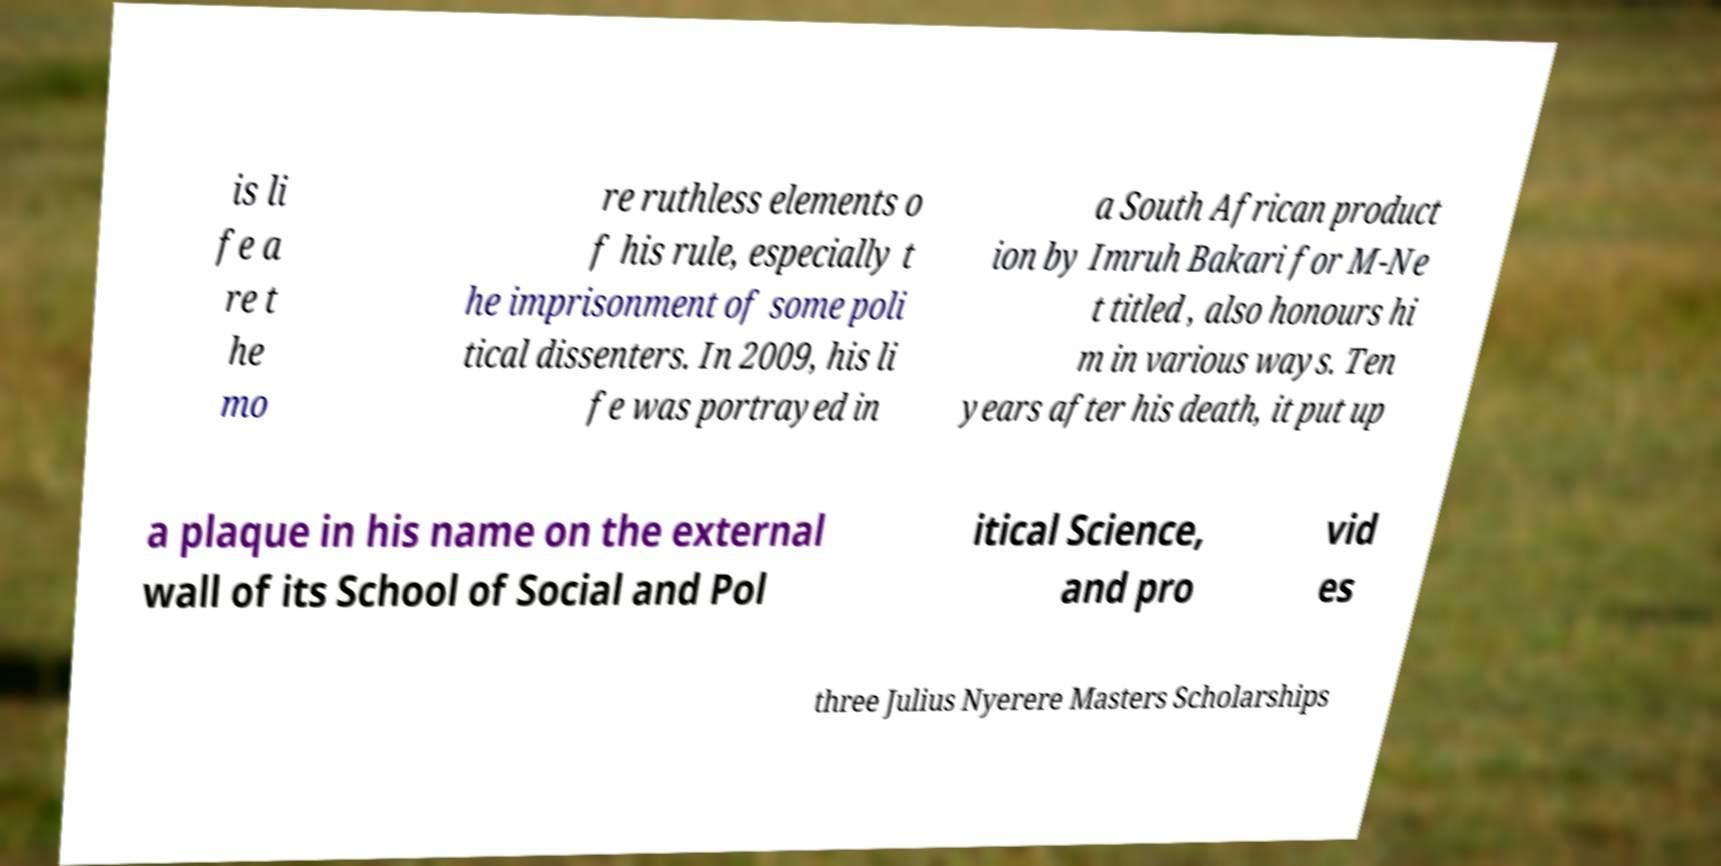Can you accurately transcribe the text from the provided image for me? is li fe a re t he mo re ruthless elements o f his rule, especially t he imprisonment of some poli tical dissenters. In 2009, his li fe was portrayed in a South African product ion by Imruh Bakari for M-Ne t titled , also honours hi m in various ways. Ten years after his death, it put up a plaque in his name on the external wall of its School of Social and Pol itical Science, and pro vid es three Julius Nyerere Masters Scholarships 